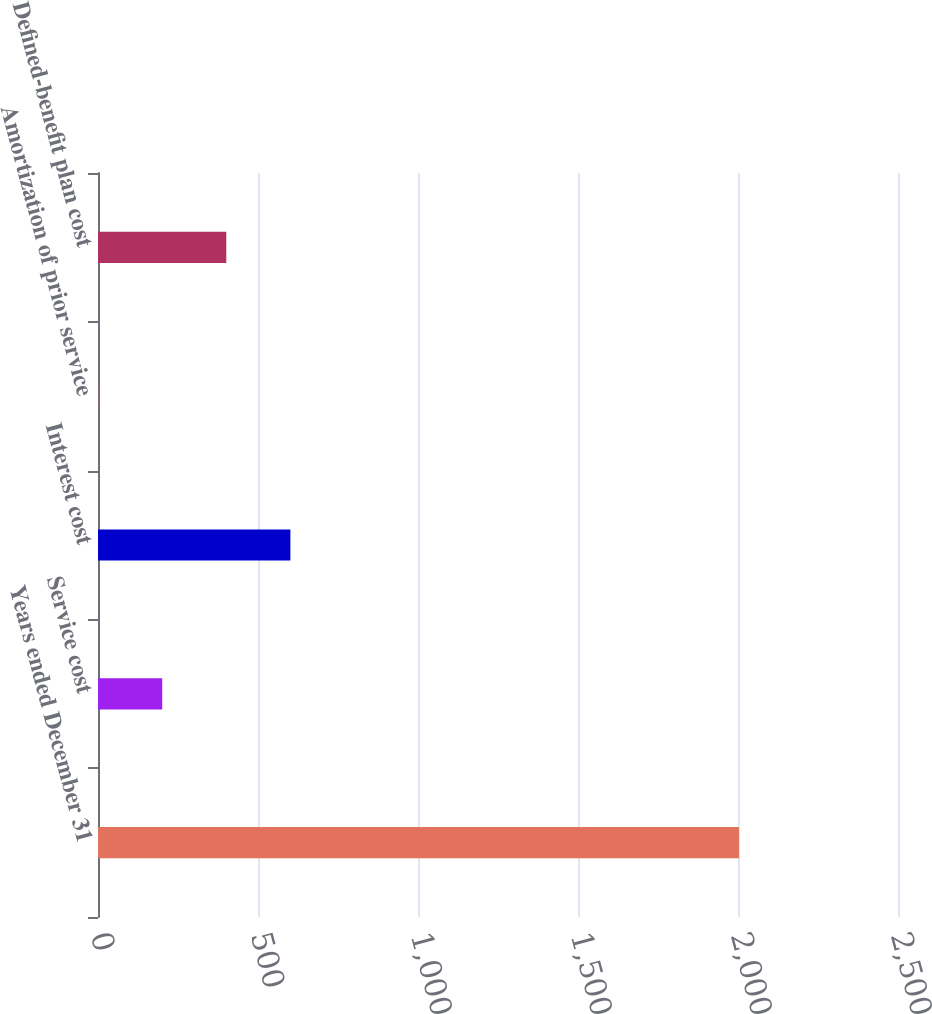Convert chart. <chart><loc_0><loc_0><loc_500><loc_500><bar_chart><fcel>Years ended December 31<fcel>Service cost<fcel>Interest cost<fcel>Amortization of prior service<fcel>Defined-benefit plan cost<nl><fcel>2003<fcel>200.66<fcel>601.18<fcel>0.4<fcel>400.92<nl></chart> 